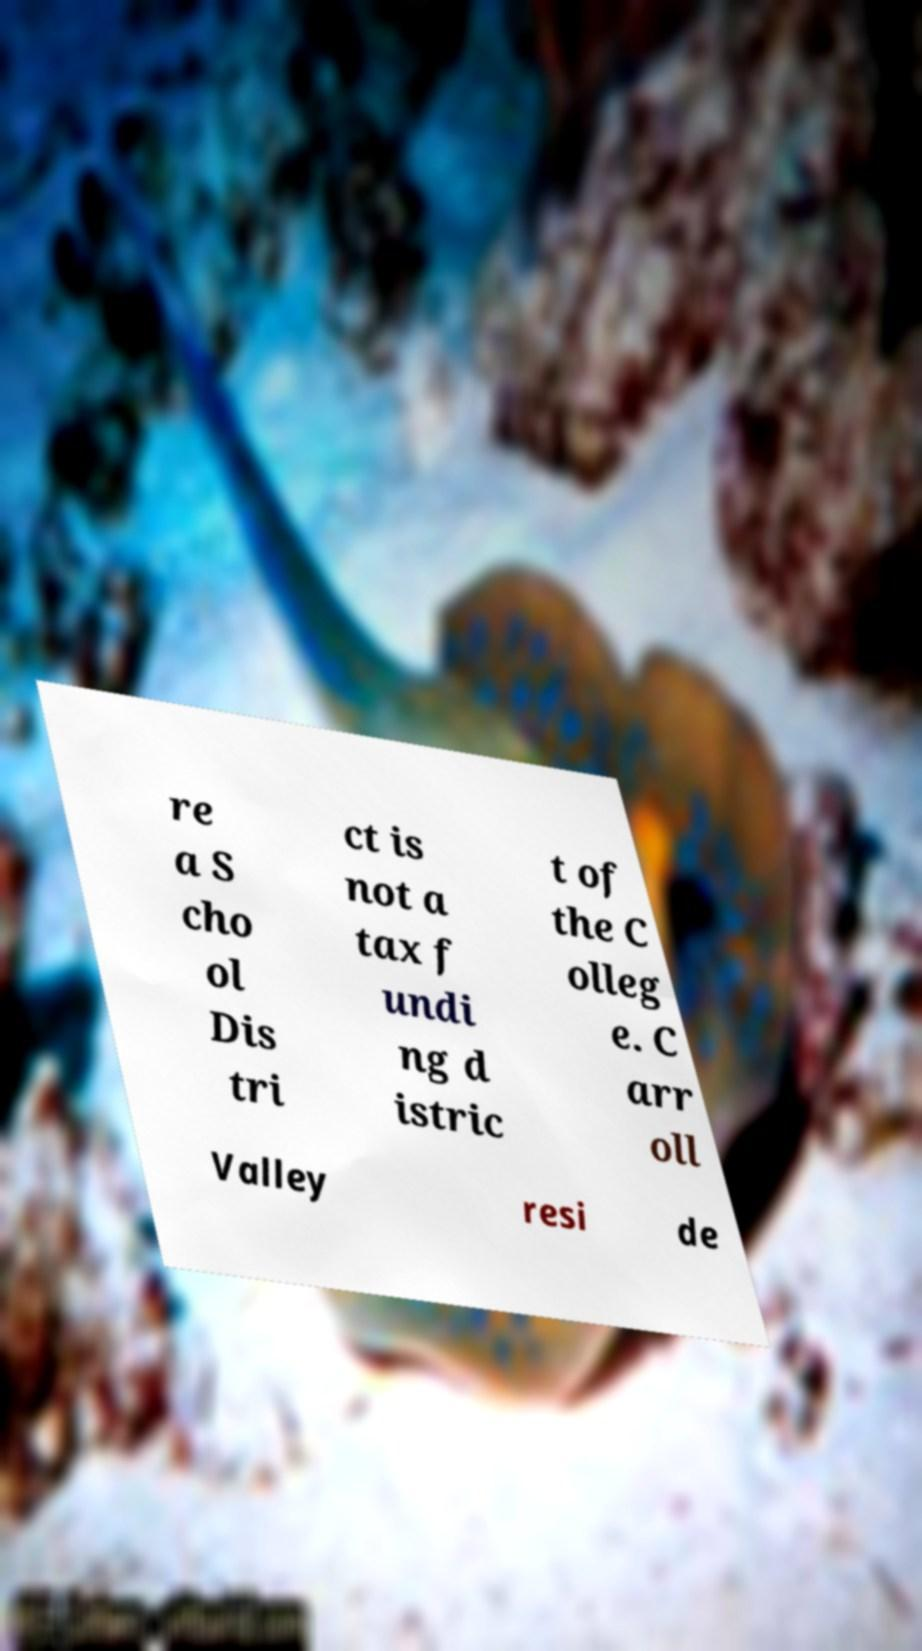Please identify and transcribe the text found in this image. re a S cho ol Dis tri ct is not a tax f undi ng d istric t of the C olleg e. C arr oll Valley resi de 